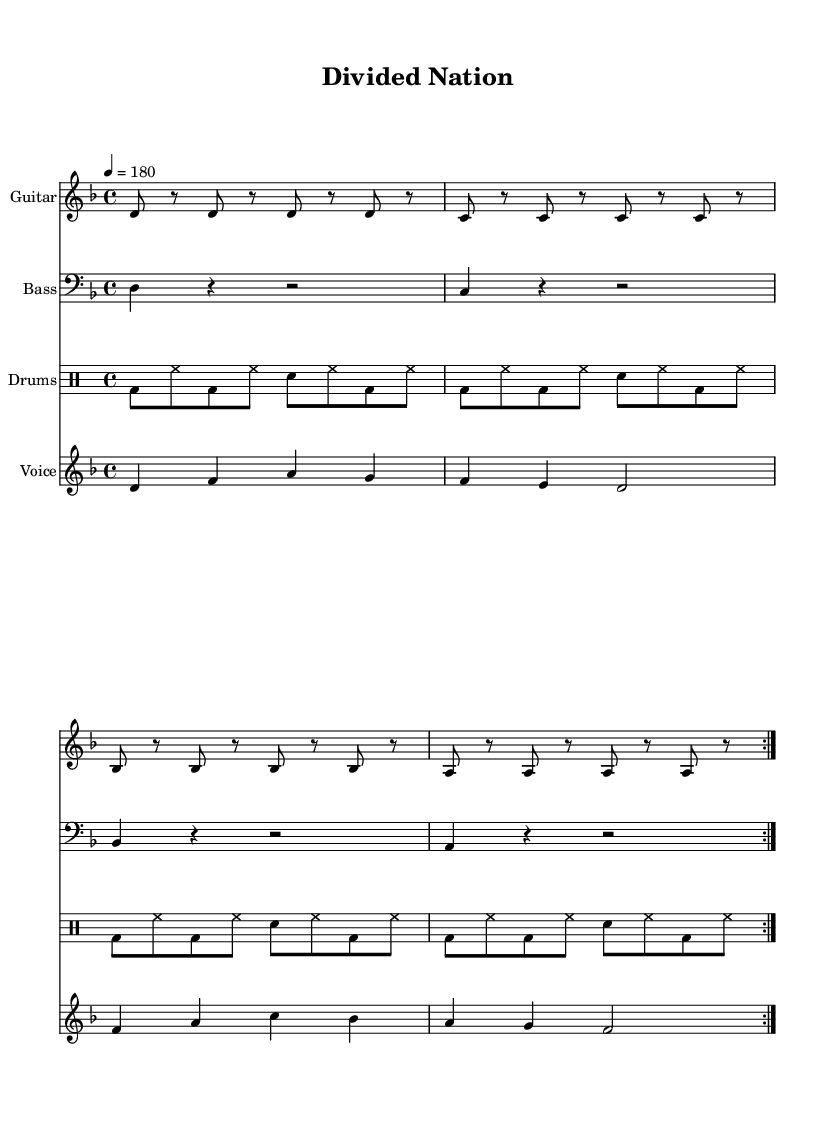What is the key signature of this music? The key signature is D minor, indicated by the presence of one flat, which is indicated on the staff. The key signature directly impacts the notes used in the melody and harmony.
Answer: D minor What is the time signature of this music? The time signature is 4/4, which is indicated at the beginning of the music. This means there are four beats in each measure, and the quarter note gets one beat.
Answer: 4/4 What is the tempo marking of the piece? The tempo marking is 180 beats per minute, indicated by the number 4 equals 180. This shows that the piece should be played at a fast pace.
Answer: 180 How many sections does the song structure have based on the lyrics? The song structure includes two sections, as there are verses and a chorus indicated by the different lyric segments. The lyrics are separated into verses and a chorus that repeat, typical in punk music.
Answer: Two What instruments are used in this composition? The instruments used are Guitar, Bass, and Drums, as noted by the separate staves for each instrument in the score. Each instrument has its own part creating a typical punk sound.
Answer: Guitar, Bass, Drums What theme does the chorus reflect in relation to its historical context? The chorus reflects the theme of division and ideological conflict, referring to the "Divided Nation" and "Cold War's creation," indicating the historical tensions during the Cold War in Germany.
Answer: Division and ideological conflict What is the driving rhythmic pattern used in the drums part? The driving rhythmic pattern used in the drums part is a consistent alternating bass drum and snare followed by hi-hat, creating a strong and upbeat punk rhythm. This is characteristic of punk music, emphasizing energy and momentum.
Answer: Alternating bass and snare 